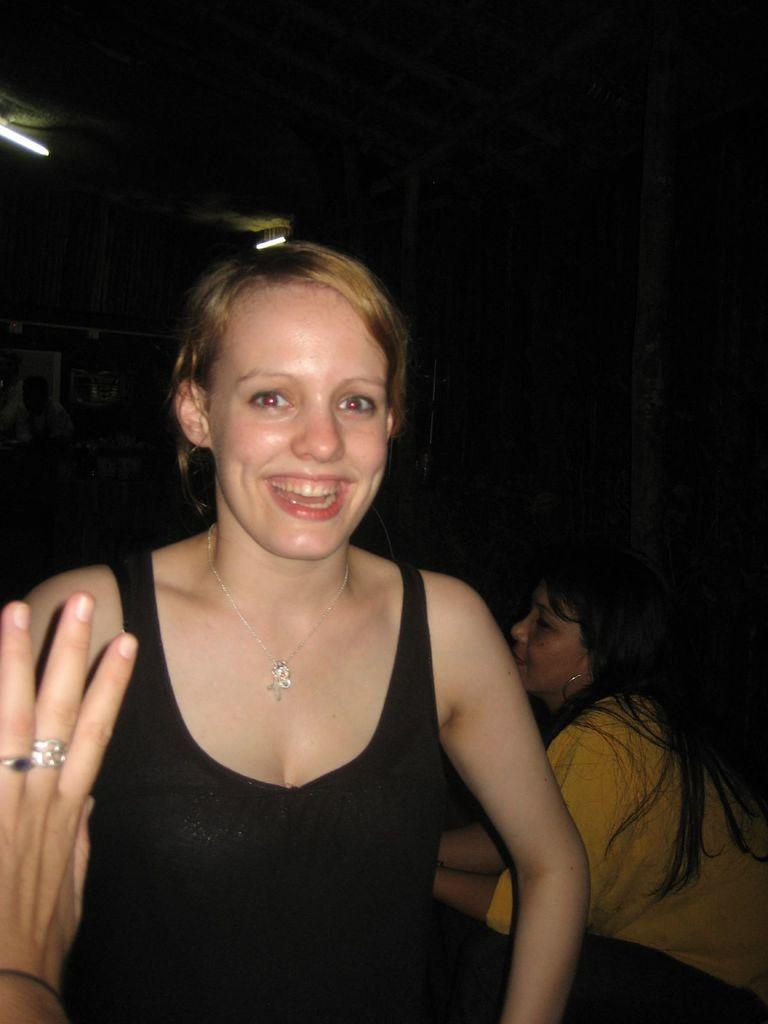Who is the main subject in the image? There is a woman in the image. What can be seen on the left side of the image? There is a person's hand on the left side of the image. How would you describe the overall lighting in the image? The background of the image is dark. Can you describe the background of the image? There is a woman visible in the background of the image, and there is light visible in the background as well. What type of prose is being recited by the woman in the image? There is no indication in the image that the woman is reciting any prose. What muscle is being flexed by the person in the image? There is no visible person flexing a muscle in the image. 